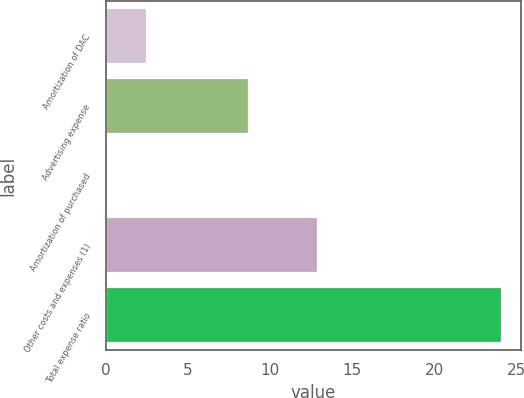Convert chart to OTSL. <chart><loc_0><loc_0><loc_500><loc_500><bar_chart><fcel>Amortization of DAC<fcel>Advertising expense<fcel>Amortization of purchased<fcel>Other costs and expenses (1)<fcel>Total expense ratio<nl><fcel>2.5<fcel>8.7<fcel>0.1<fcel>12.9<fcel>24.1<nl></chart> 